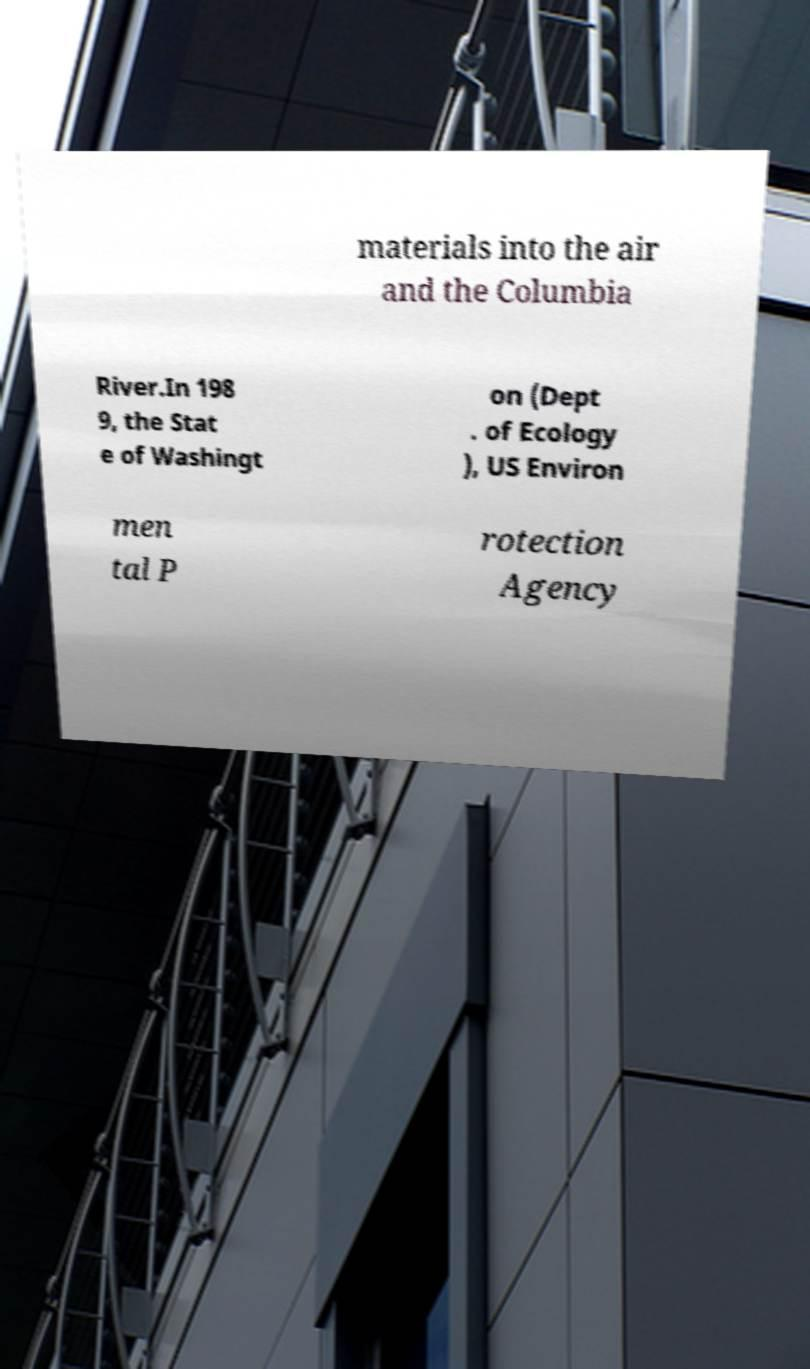Can you accurately transcribe the text from the provided image for me? materials into the air and the Columbia River.In 198 9, the Stat e of Washingt on (Dept . of Ecology ), US Environ men tal P rotection Agency 